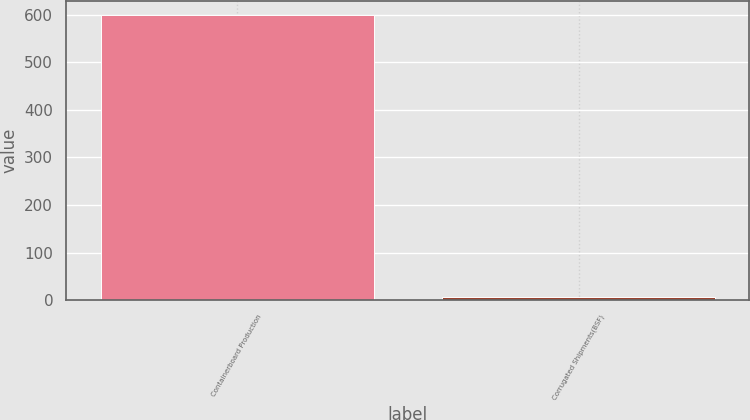Convert chart to OTSL. <chart><loc_0><loc_0><loc_500><loc_500><bar_chart><fcel>Containerboard Production<fcel>Corrugated Shipments(BSF)<nl><fcel>599<fcel>7.4<nl></chart> 